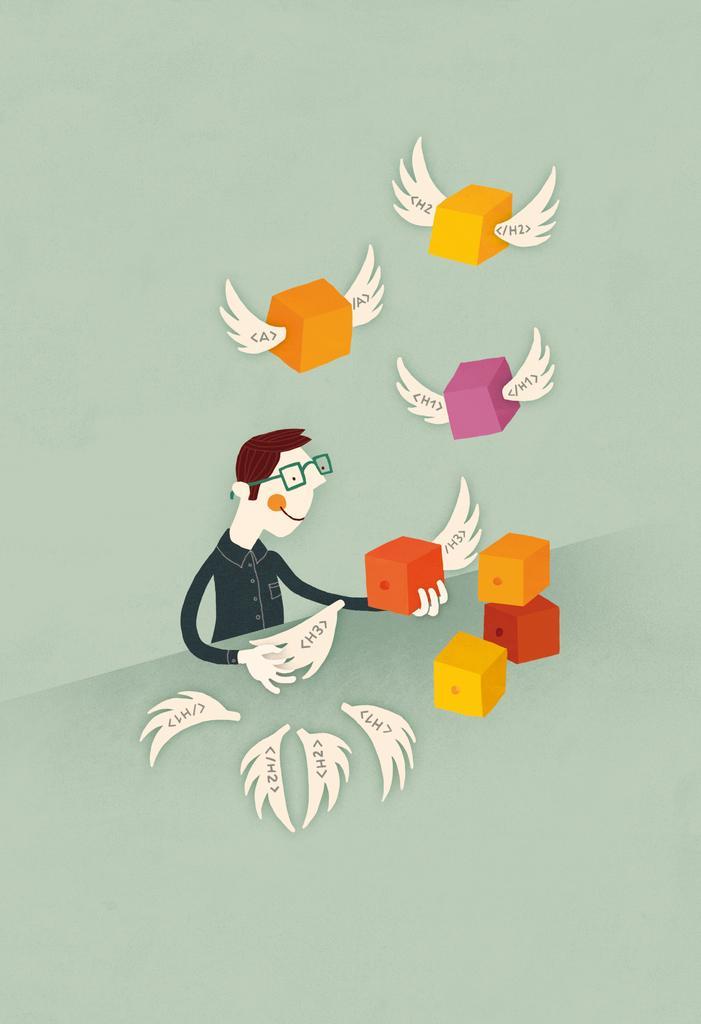In one or two sentences, can you explain what this image depicts? In this image we can see the cartoon person sitting and holding objects. and we can see the many animated cubes with wings. 